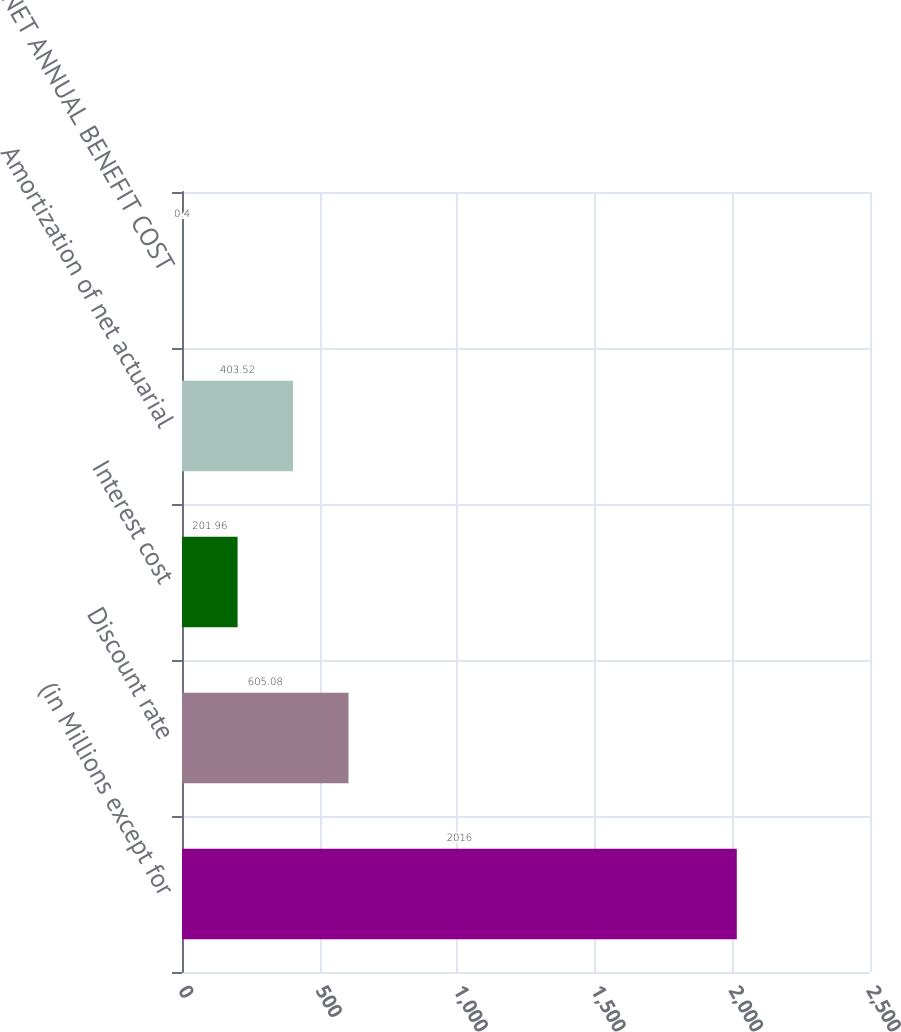<chart> <loc_0><loc_0><loc_500><loc_500><bar_chart><fcel>(in Millions except for<fcel>Discount rate<fcel>Interest cost<fcel>Amortization of net actuarial<fcel>NET ANNUAL BENEFIT COST<nl><fcel>2016<fcel>605.08<fcel>201.96<fcel>403.52<fcel>0.4<nl></chart> 